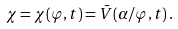Convert formula to latex. <formula><loc_0><loc_0><loc_500><loc_500>\chi = \chi ( \varphi , t ) = \bar { V } ( \alpha / \varphi , t ) \, .</formula> 